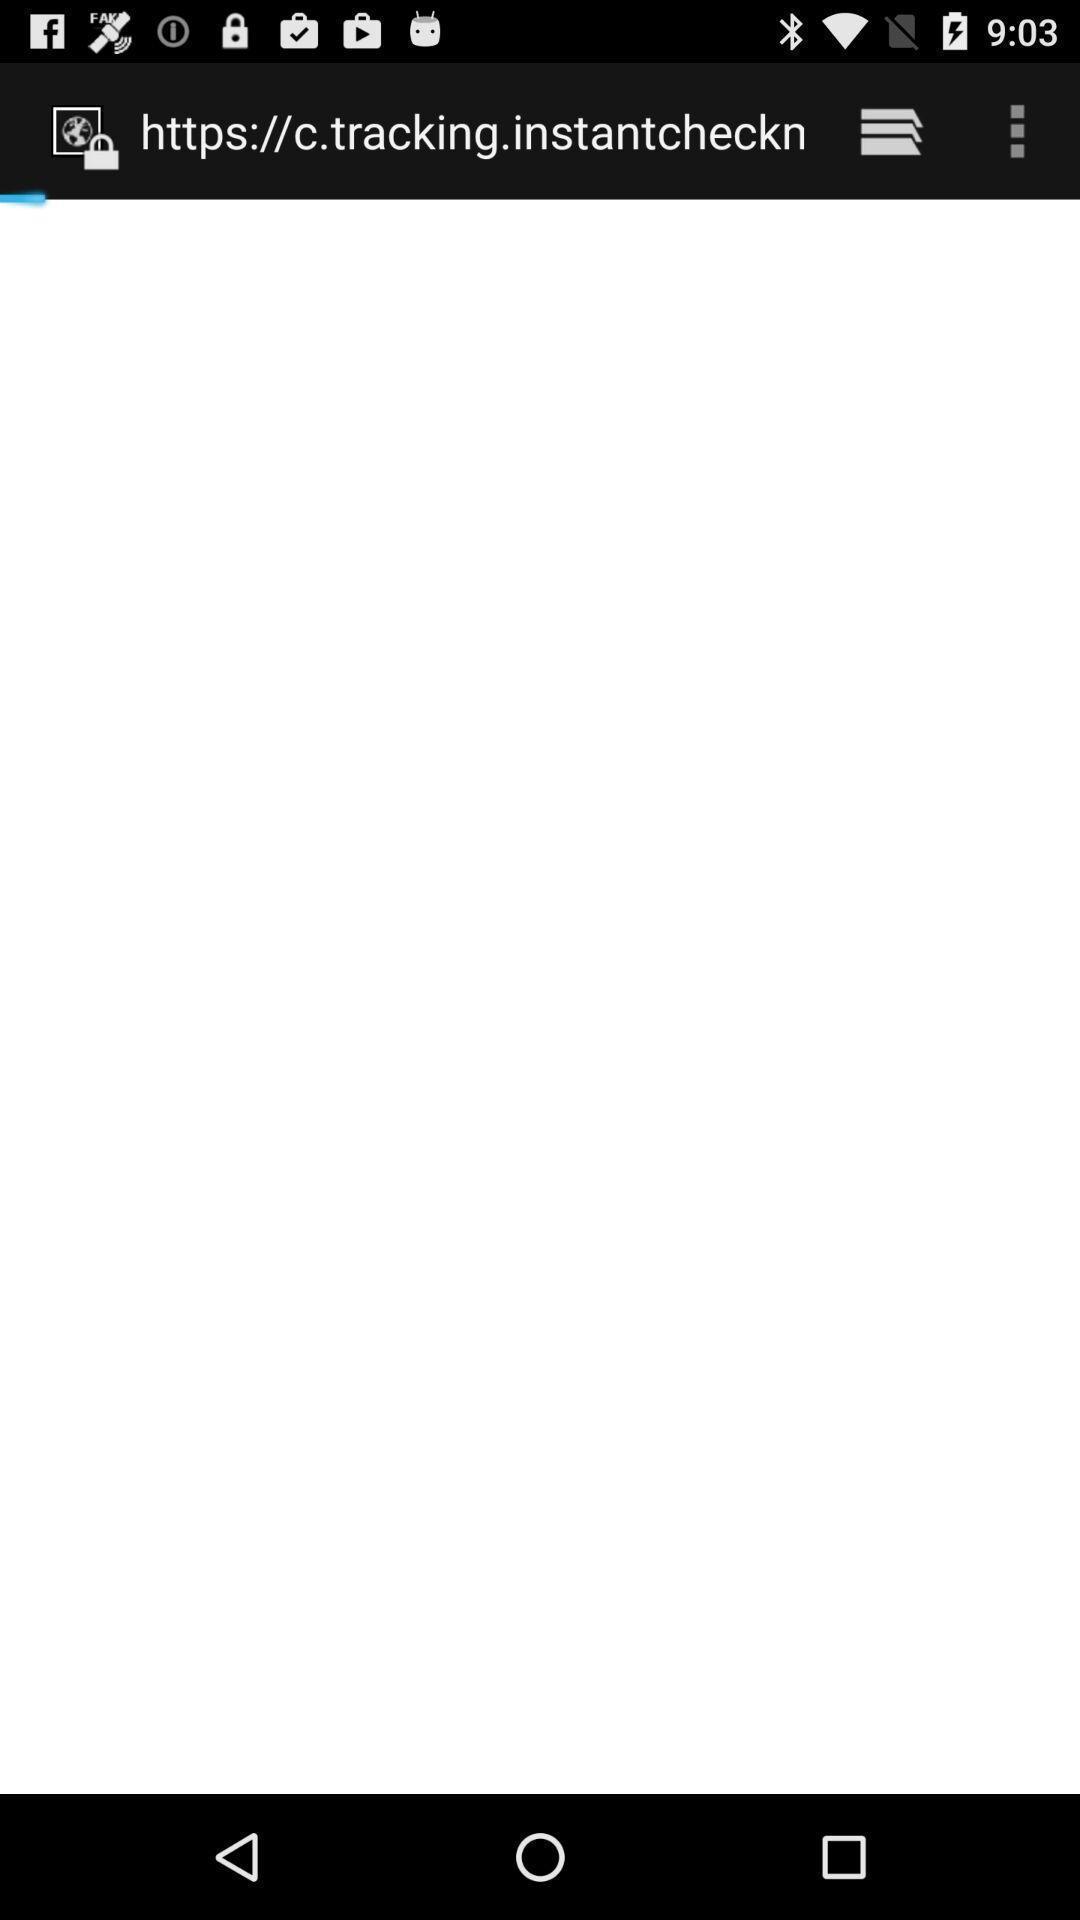Describe the content in this image. Page displaying website link and other options. 